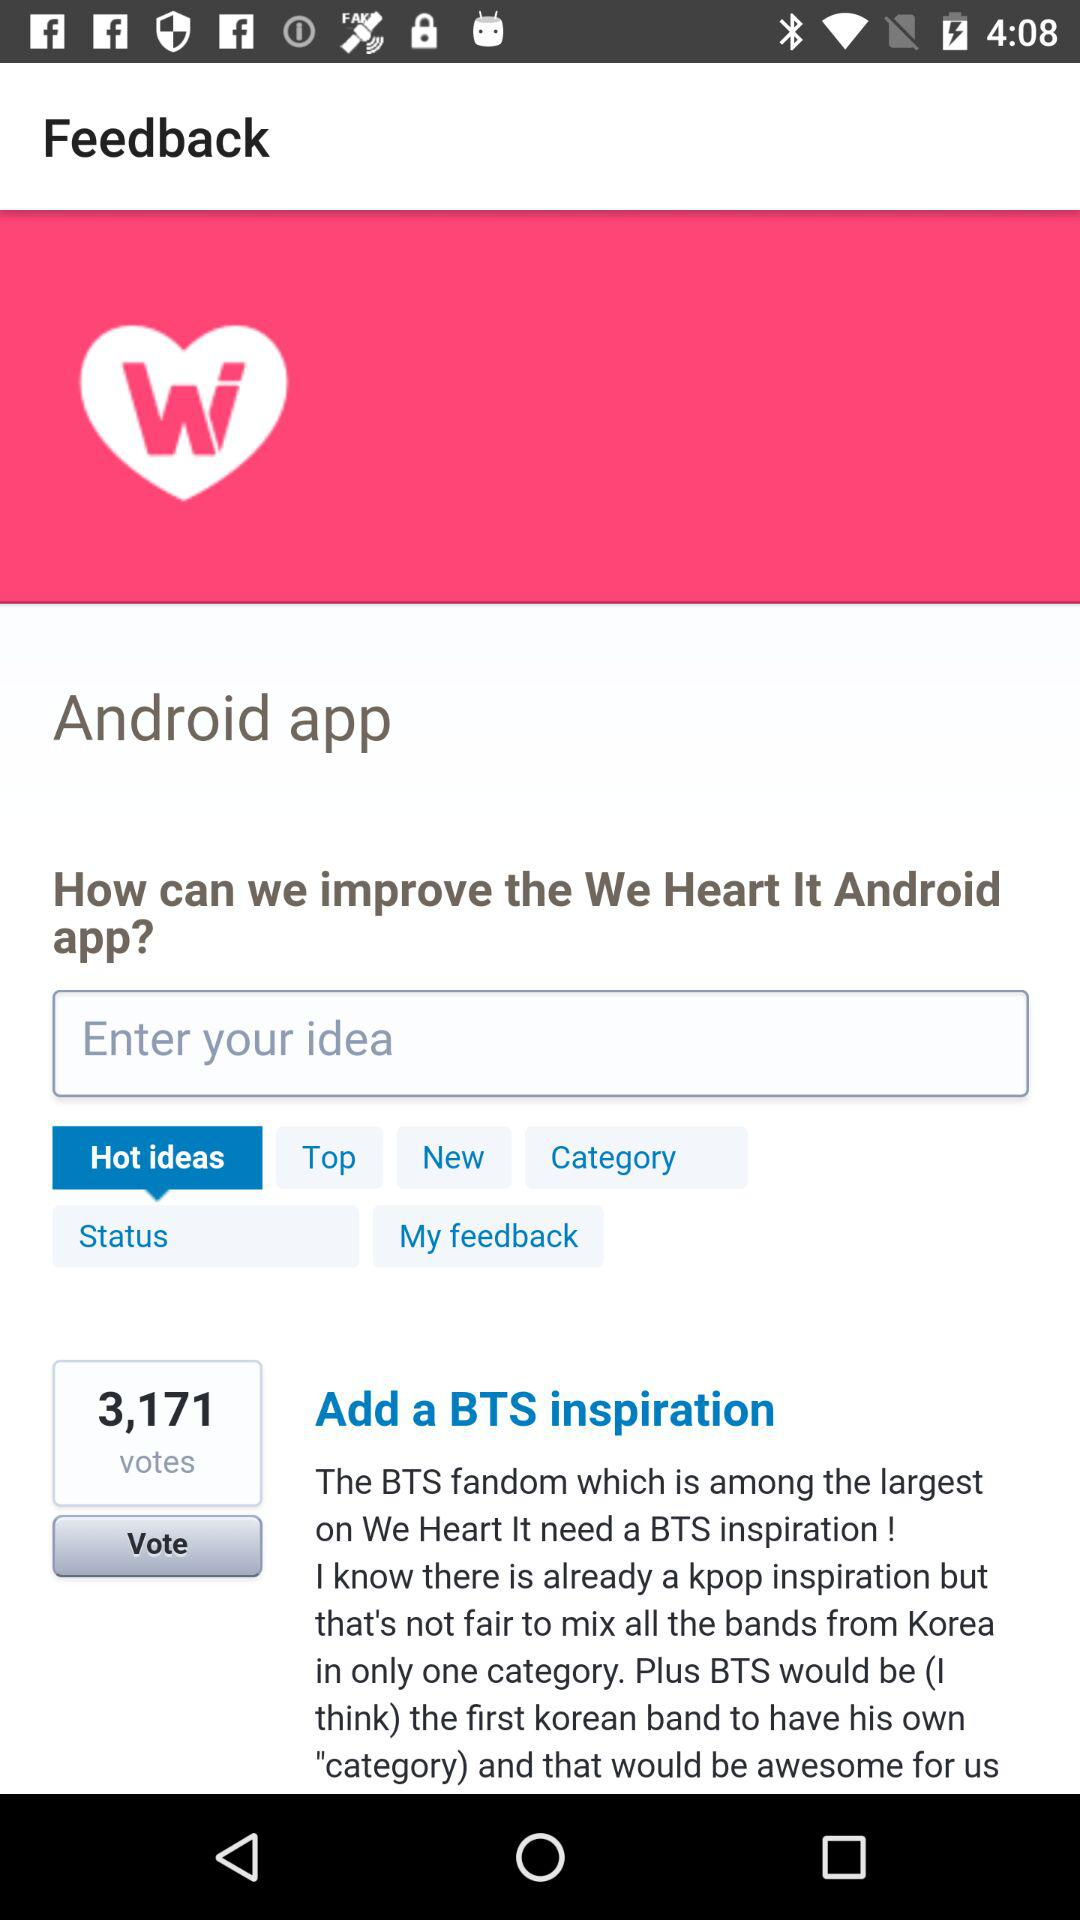How many votes have come in for "Add a BTS inspiration"? The number of votes that have come in is 3,171. 